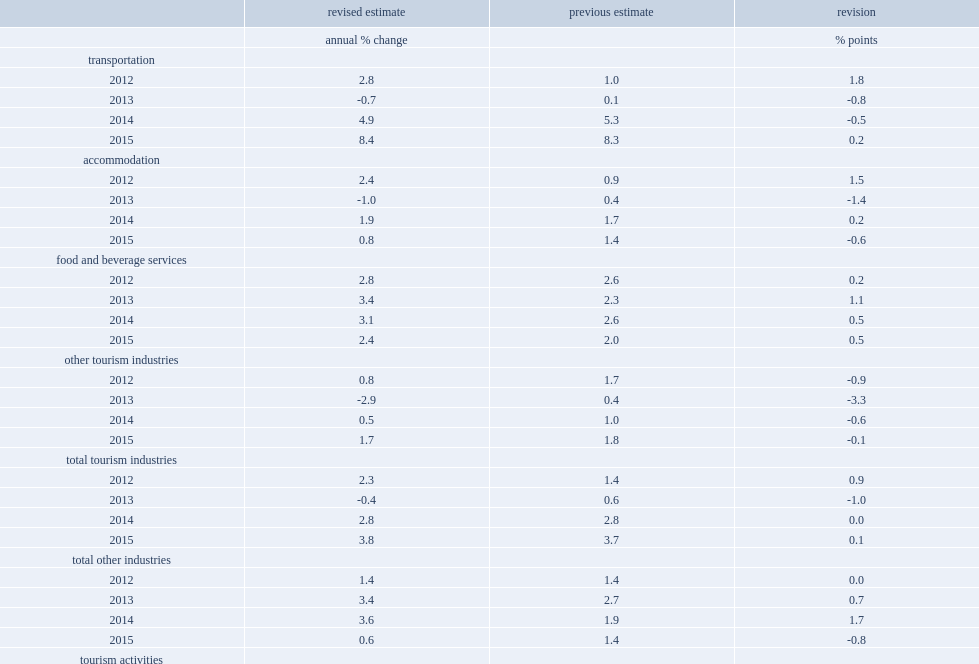How many percentage points of tourism gdp was revised down in 2015? 0.2. What was the percent of tourism gdp increased in 2015? 2.9. 